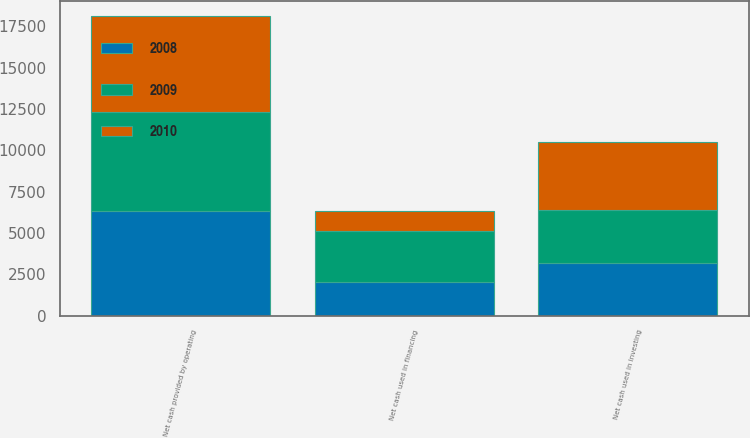Convert chart. <chart><loc_0><loc_0><loc_500><loc_500><stacked_bar_chart><ecel><fcel>Net cash provided by operating<fcel>Net cash used in investing<fcel>Net cash used in financing<nl><fcel>2010<fcel>5787<fcel>4152<fcel>1232<nl><fcel>2008<fcel>6336<fcel>3202<fcel>2024<nl><fcel>2009<fcel>5988<fcel>3165<fcel>3073<nl></chart> 